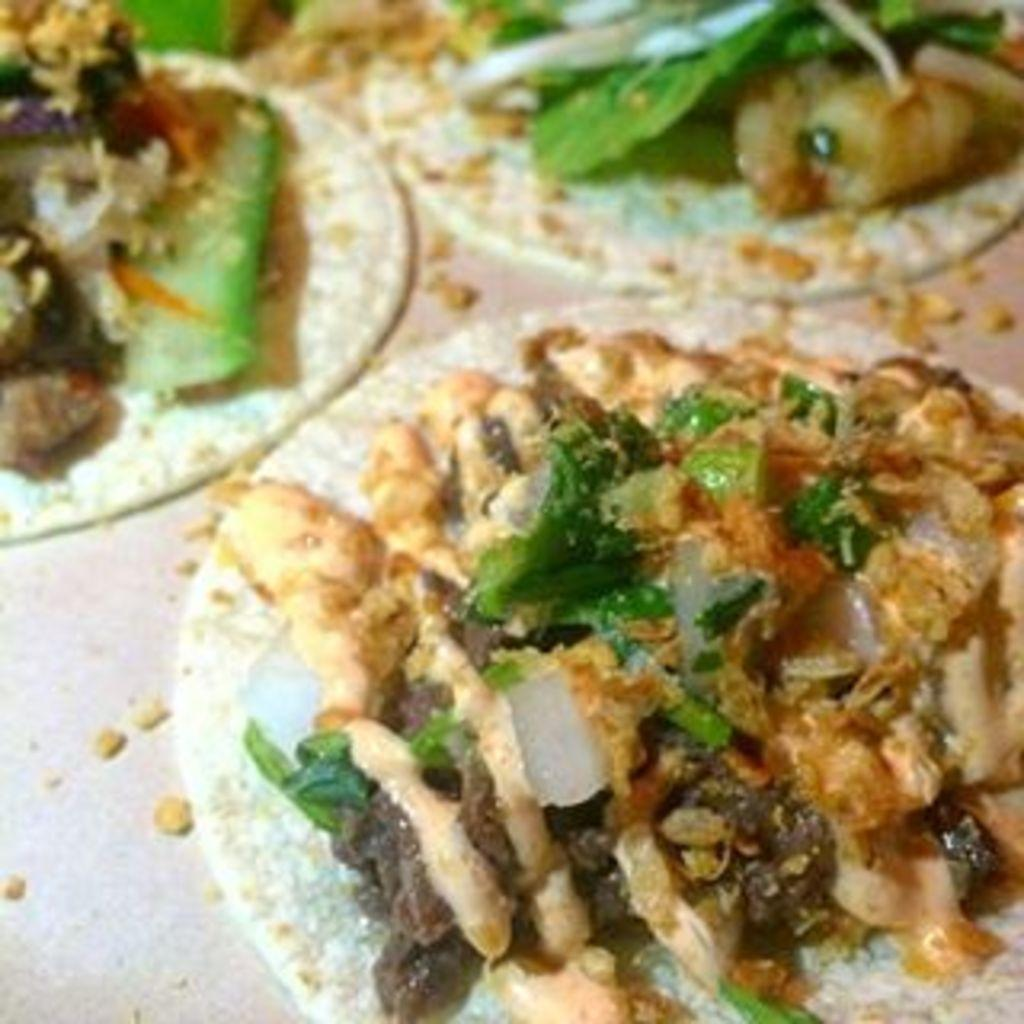What is the primary subject of the image? The primary subject of the image is a table with food items on it. Can you describe the food items on the table? Unfortunately, the provided facts do not specify the types of food items on the table. What might be used to consume the food items on the table? It is likely that utensils or plates are present, but the provided facts do not mention them. What type of crack can be seen in the image? There is no crack present in the image; it features a table with food items on it. 